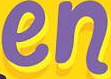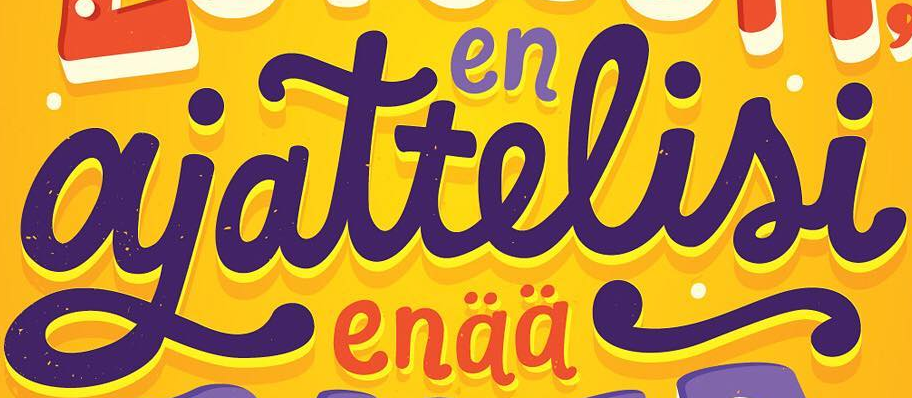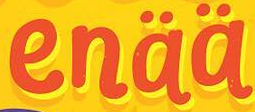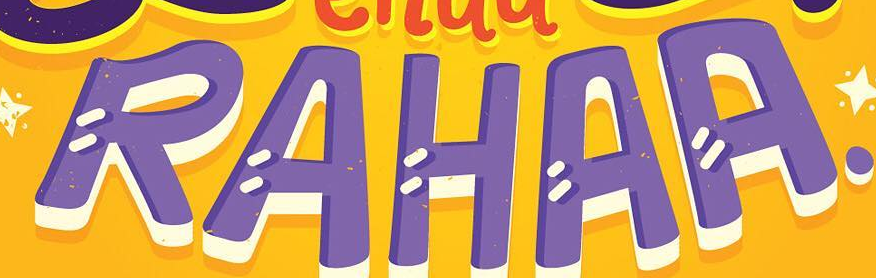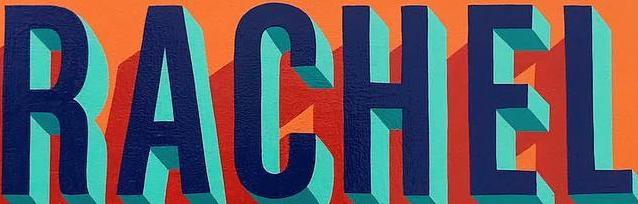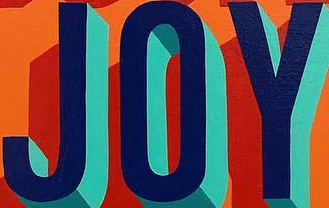What text appears in these images from left to right, separated by a semicolon? en; ajattelisi; enää; RAHAA; RACHEL; JOY 